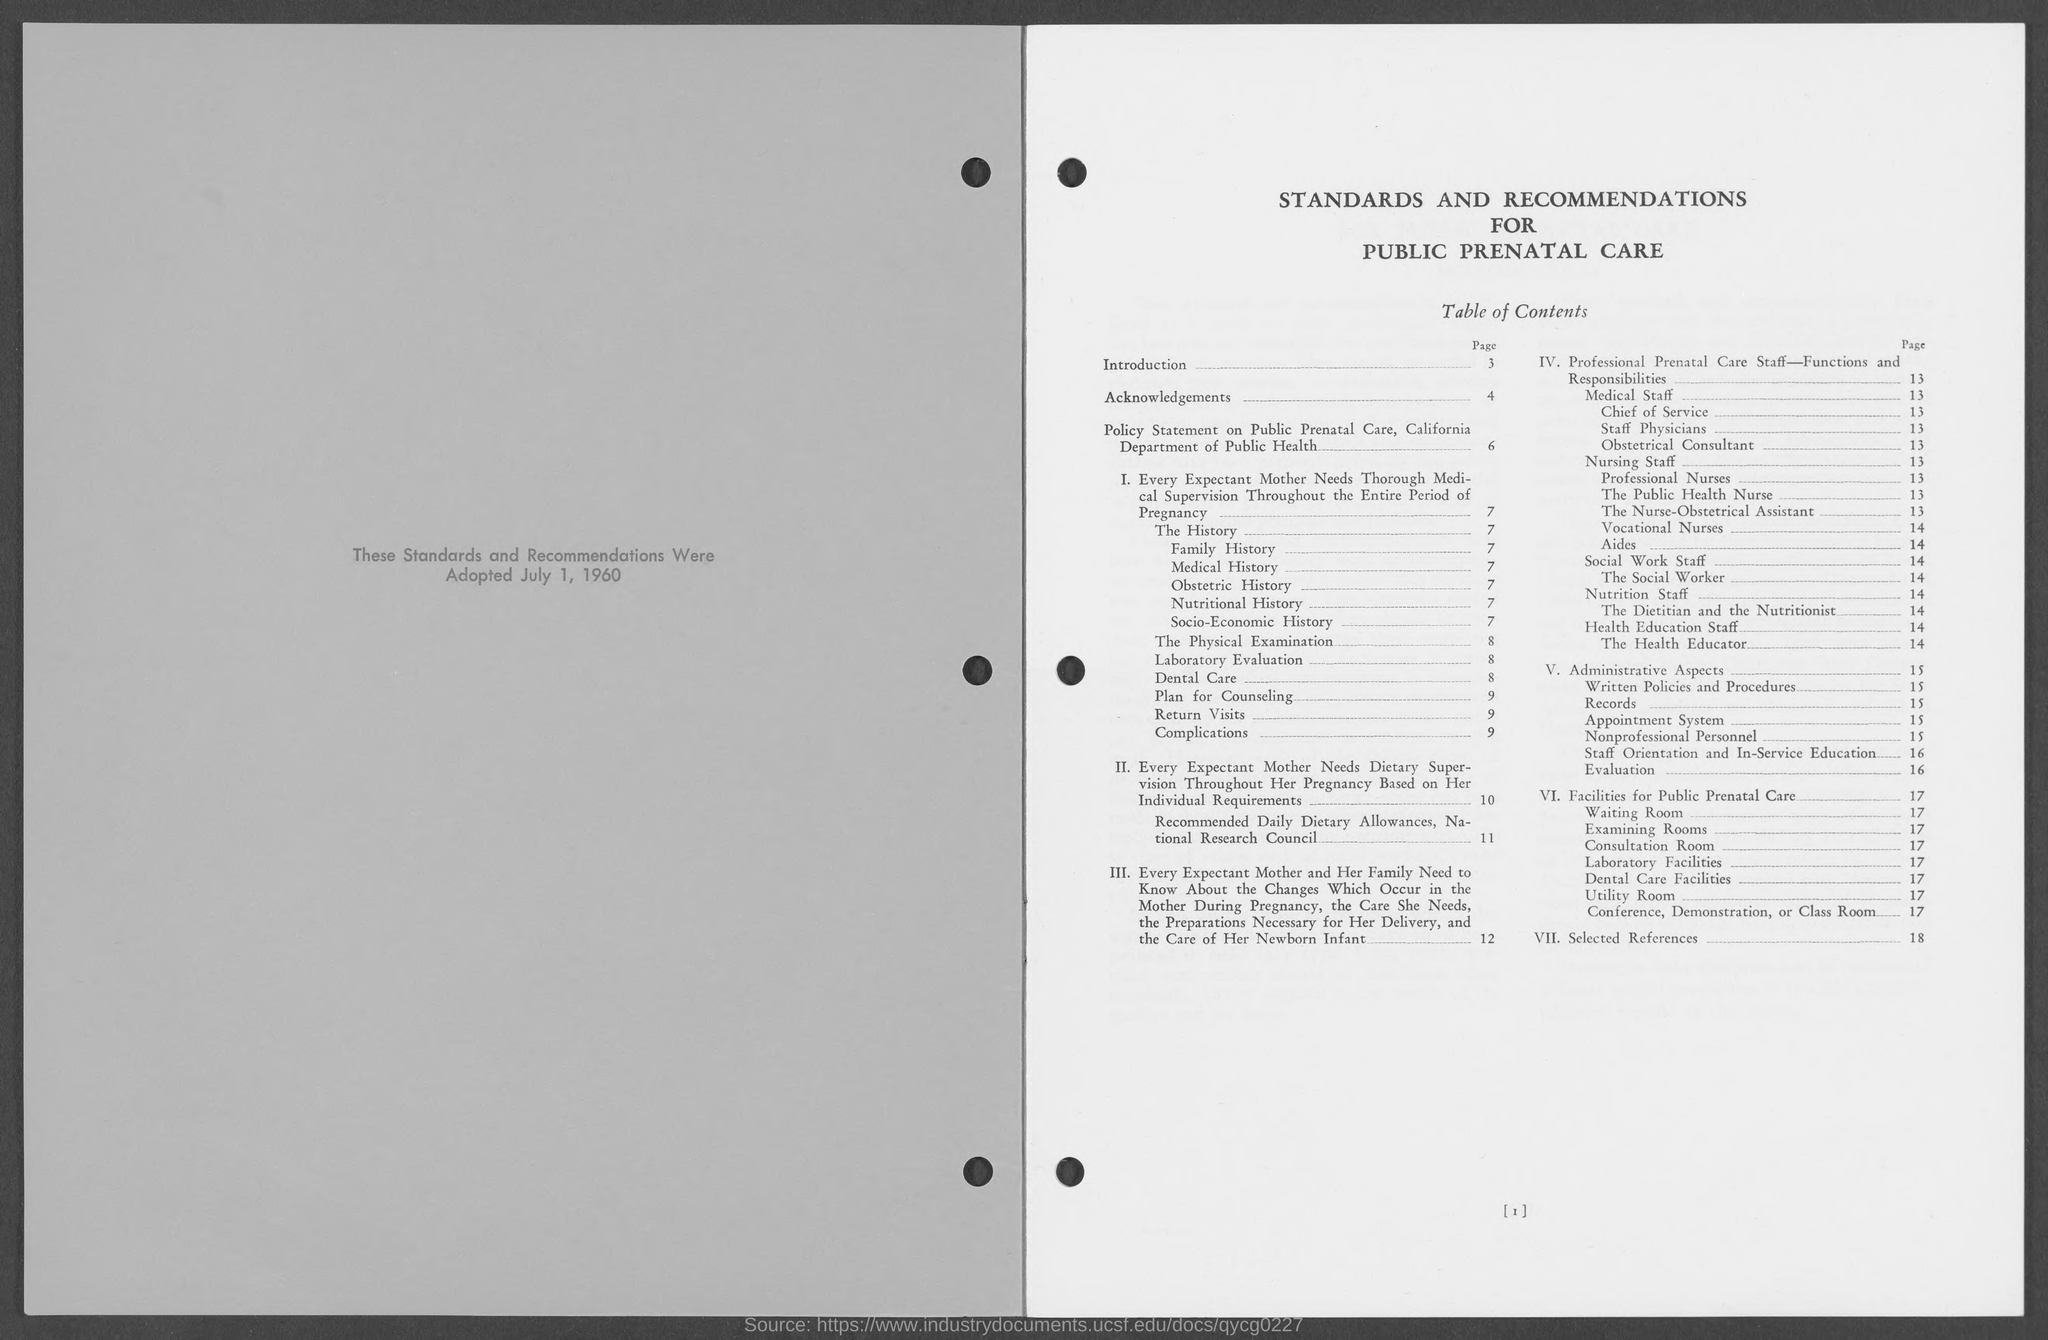When was the standards and recommendations adopted?
Provide a succinct answer. July 1, 1960. What is the date on the left hand side of the document?
Your answer should be compact. July 1, 1960. What is the topmost heading on the right hand side of the document?
Provide a short and direct response. Standards and Recommendations For Public Prenatal Care. What is the page number of the topic Acknowledgements"?
Provide a short and direct response. 4. What is the page number of "Nursing staff"?
Keep it short and to the point. 13. What is the page number of the topic "Evaluation"?
Offer a very short reply. 16. What is the page number of the topic "Selected References"?
Give a very brief answer. 18. What is the page number of the topic "Nutritional History"?
Provide a short and direct response. 7. 